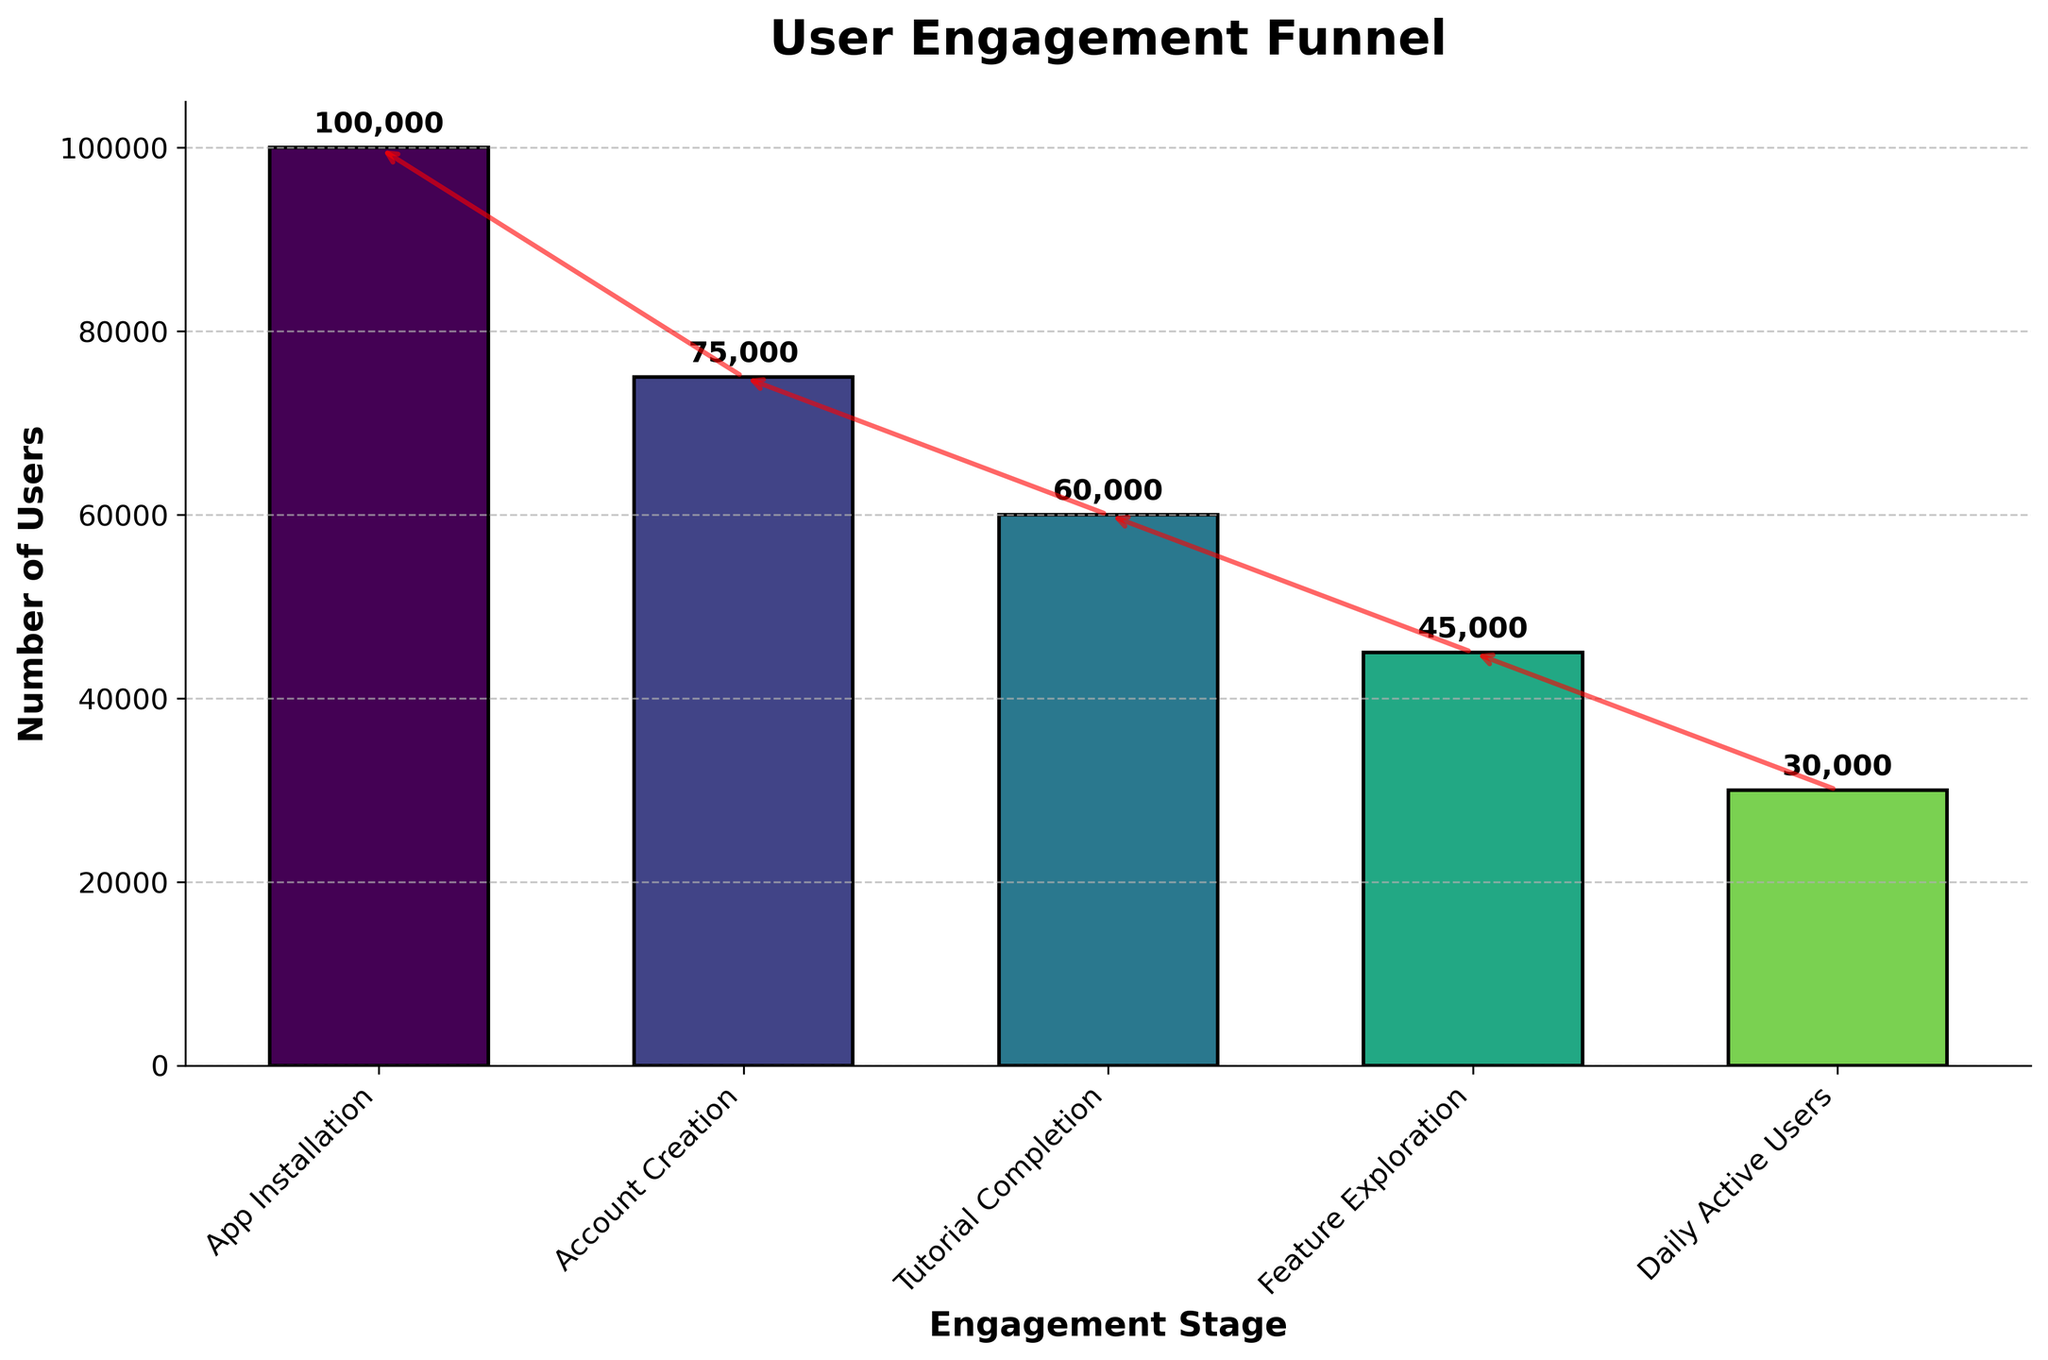What's the title of the figure? The title of the figure is located at the top and clearly states the main subject of the chart.
Answer: User Engagement Funnel How many stages are shown in the funnel chart? By observing the x-axis labels, we can count the different stages presented.
Answer: 5 What is the difference in user count between App Installation and Daily Active Users? Subtract the number of Daily Active Users from the number of App Installations (100,000 - 30,000).
Answer: 70,000 Which stage has the highest user dropout? Dropout is highest where the reduction in user count from one stage to the next is greatest. Comparing decreases: 25,000 (App Installation to Account Creation), 15,000 (Account Creation to Tutorial Completion), 15,000 (Tutorial Completion to Feature Exploration), and 15,000 (Feature Exploration to Daily Active Users). The largest dropout is at the first stage.
Answer: App Installation to Account Creation What is the user count at the Feature Exploration stage? The value for Feature Exploration can be read directly from the corresponding bar.
Answer: 45,000 By what percentage does the user count decrease from App Installation to Account Creation? Calculate the percentage decrease using (100,000 - 75,000) / 100,000 * 100.
Answer: 25% Is the drop between Feature Exploration and Daily Active Users larger or smaller than the drop between Account Creation and Tutorial Completion? By comparing drops: 15,000 (Feature Exploration to Daily Active Users) and 15,000 (Account Creation to Tutorial Completion), they are equal.
Answer: Equal What trend is shown by the red arrows in the chart? The red arrows indicate the direction of user flow through the stages, decreasing from left to right.
Answer: Decreasing How many users do not complete the tutorial after creating an account? Subtract Tutorial Completion users from Account Creation users (75,000 - 60,000).
Answer: 15,000 